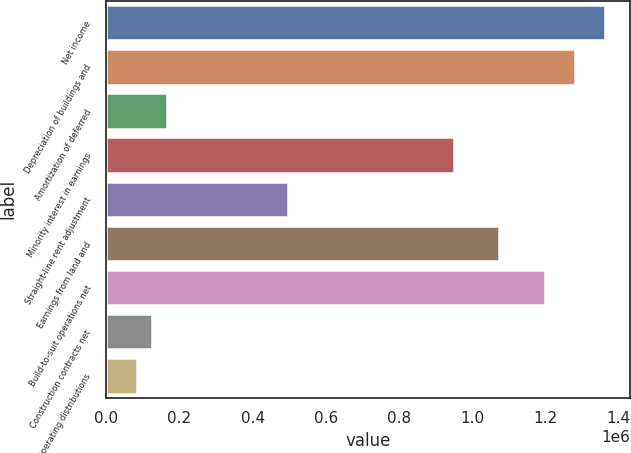Convert chart. <chart><loc_0><loc_0><loc_500><loc_500><bar_chart><fcel>Net income<fcel>Depreciation of buildings and<fcel>Amortization of deferred<fcel>Minority interest in earnings<fcel>Straight-line rent adjustment<fcel>Earnings from land and<fcel>Build-to-suit operations net<fcel>Construction contracts net<fcel>Operating distributions<nl><fcel>1.36414e+06<fcel>1.2815e+06<fcel>165825<fcel>950928<fcel>496394<fcel>1.07489e+06<fcel>1.19885e+06<fcel>124504<fcel>83182.4<nl></chart> 